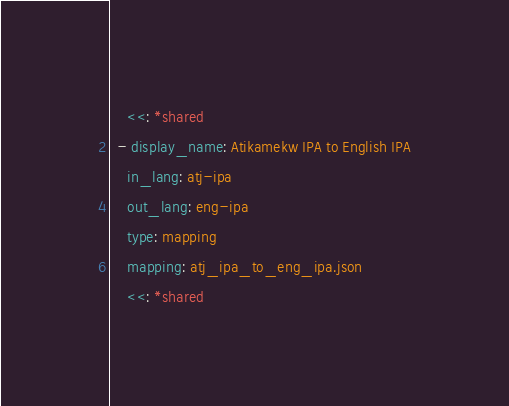Convert code to text. <code><loc_0><loc_0><loc_500><loc_500><_YAML_>    <<: *shared
  - display_name: Atikamekw IPA to English IPA
    in_lang: atj-ipa
    out_lang: eng-ipa
    type: mapping
    mapping: atj_ipa_to_eng_ipa.json
    <<: *shared</code> 